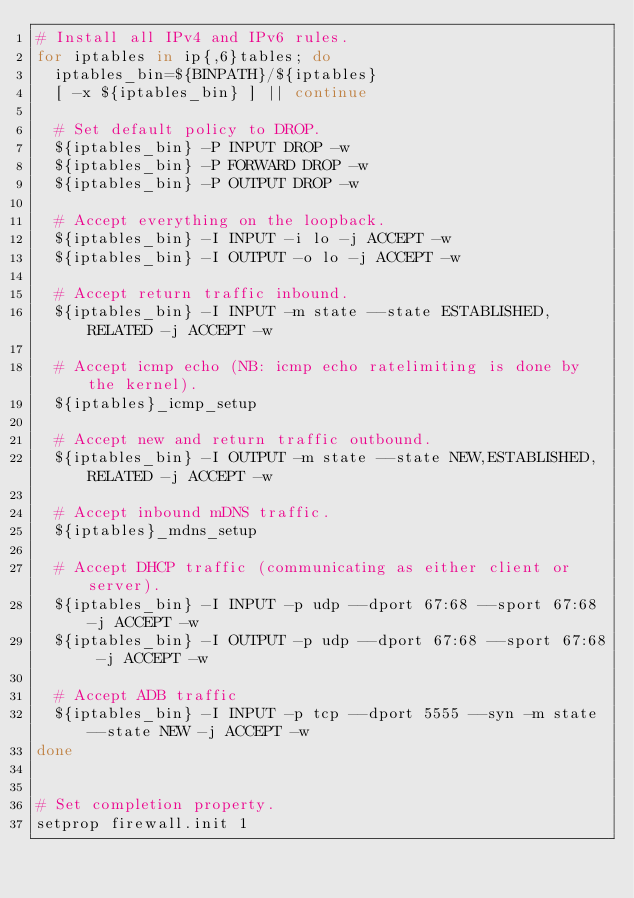<code> <loc_0><loc_0><loc_500><loc_500><_Bash_># Install all IPv4 and IPv6 rules.
for iptables in ip{,6}tables; do
  iptables_bin=${BINPATH}/${iptables}
  [ -x ${iptables_bin} ] || continue

  # Set default policy to DROP.
  ${iptables_bin} -P INPUT DROP -w
  ${iptables_bin} -P FORWARD DROP -w
  ${iptables_bin} -P OUTPUT DROP -w

  # Accept everything on the loopback.
  ${iptables_bin} -I INPUT -i lo -j ACCEPT -w
  ${iptables_bin} -I OUTPUT -o lo -j ACCEPT -w

  # Accept return traffic inbound.
  ${iptables_bin} -I INPUT -m state --state ESTABLISHED,RELATED -j ACCEPT -w

  # Accept icmp echo (NB: icmp echo ratelimiting is done by the kernel).
  ${iptables}_icmp_setup

  # Accept new and return traffic outbound.
  ${iptables_bin} -I OUTPUT -m state --state NEW,ESTABLISHED,RELATED -j ACCEPT -w

  # Accept inbound mDNS traffic.
  ${iptables}_mdns_setup

  # Accept DHCP traffic (communicating as either client or server).
  ${iptables_bin} -I INPUT -p udp --dport 67:68 --sport 67:68 -j ACCEPT -w
  ${iptables_bin} -I OUTPUT -p udp --dport 67:68 --sport 67:68 -j ACCEPT -w

  # Accept ADB traffic
  ${iptables_bin} -I INPUT -p tcp --dport 5555 --syn -m state --state NEW -j ACCEPT -w
done


# Set completion property.
setprop firewall.init 1
</code> 